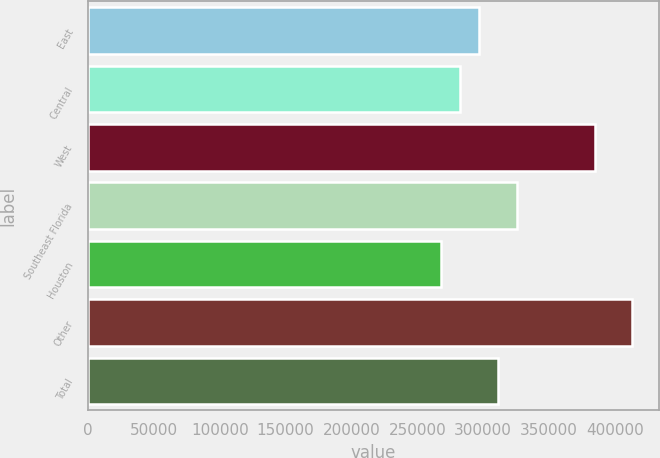Convert chart to OTSL. <chart><loc_0><loc_0><loc_500><loc_500><bar_chart><fcel>East<fcel>Central<fcel>West<fcel>Southeast Florida<fcel>Houston<fcel>Other<fcel>Total<nl><fcel>297000<fcel>282500<fcel>385000<fcel>326000<fcel>268000<fcel>413000<fcel>311500<nl></chart> 